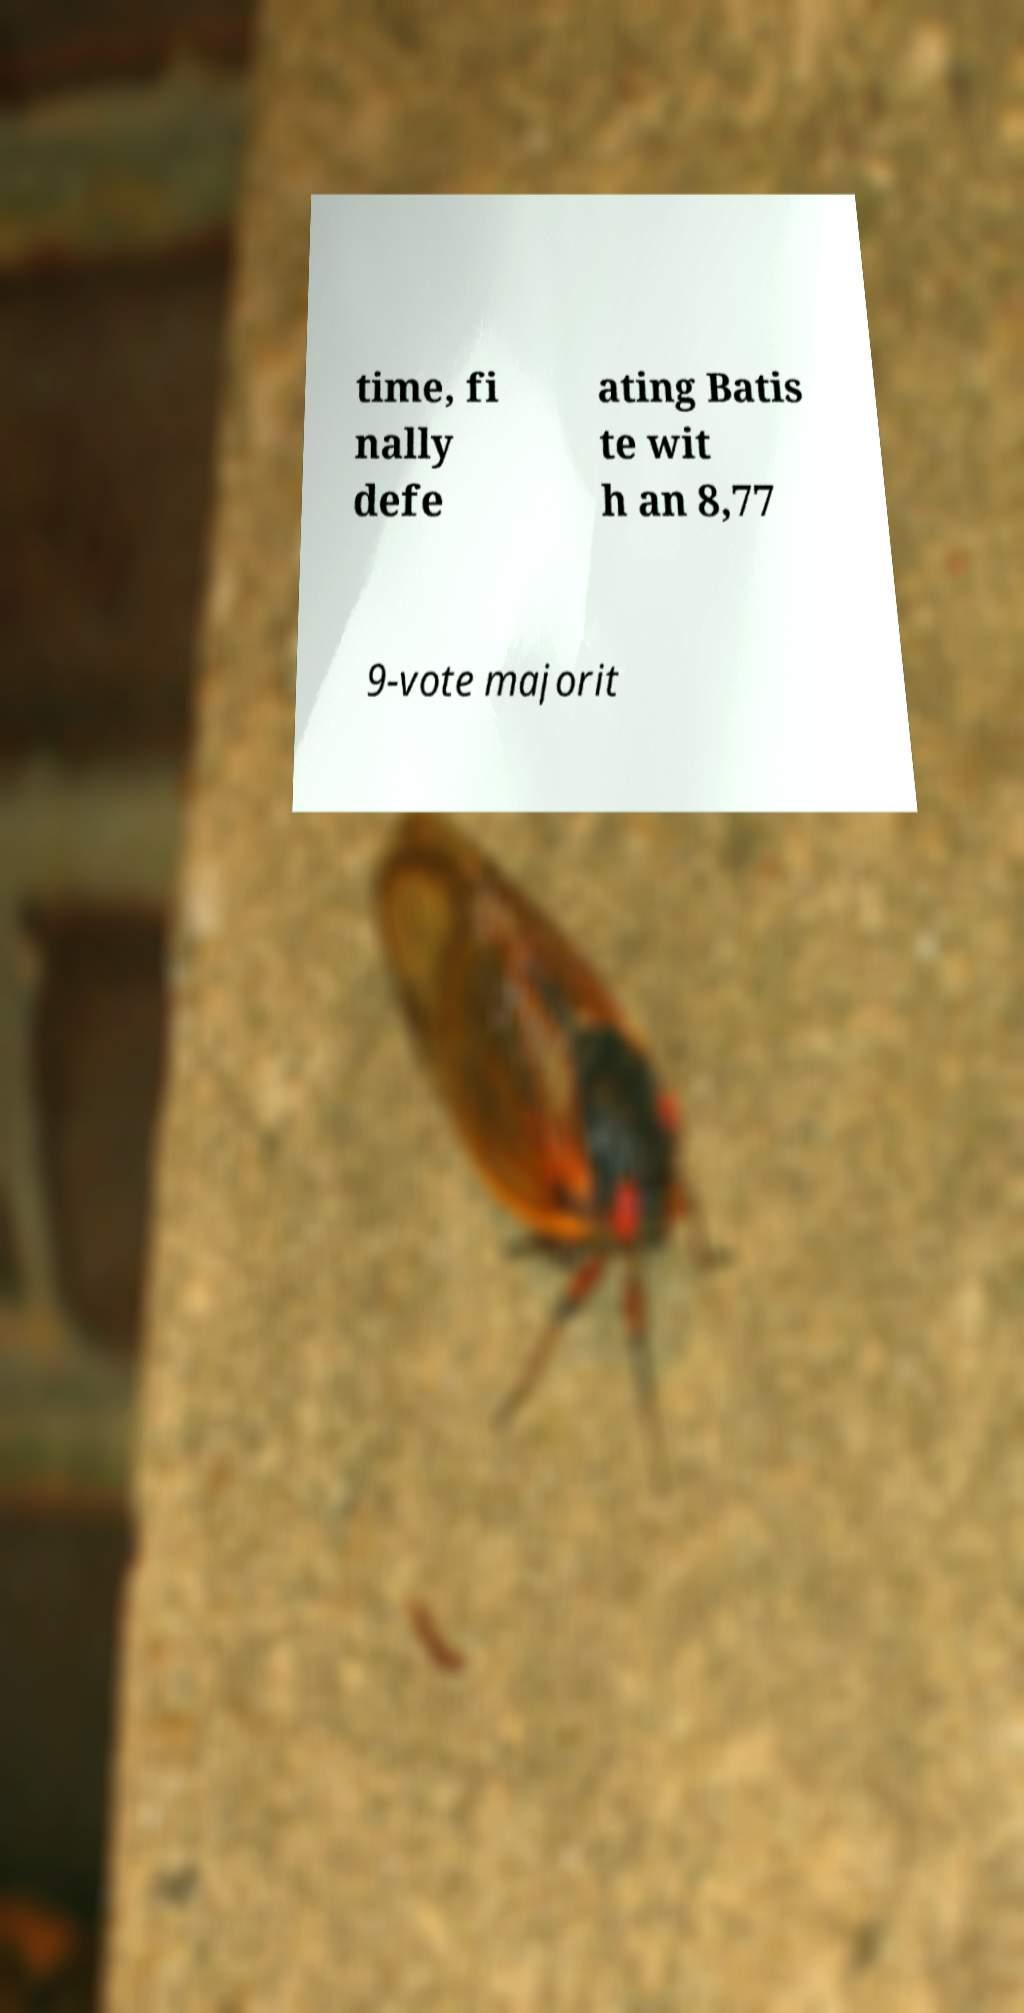Can you accurately transcribe the text from the provided image for me? time, fi nally defe ating Batis te wit h an 8,77 9-vote majorit 